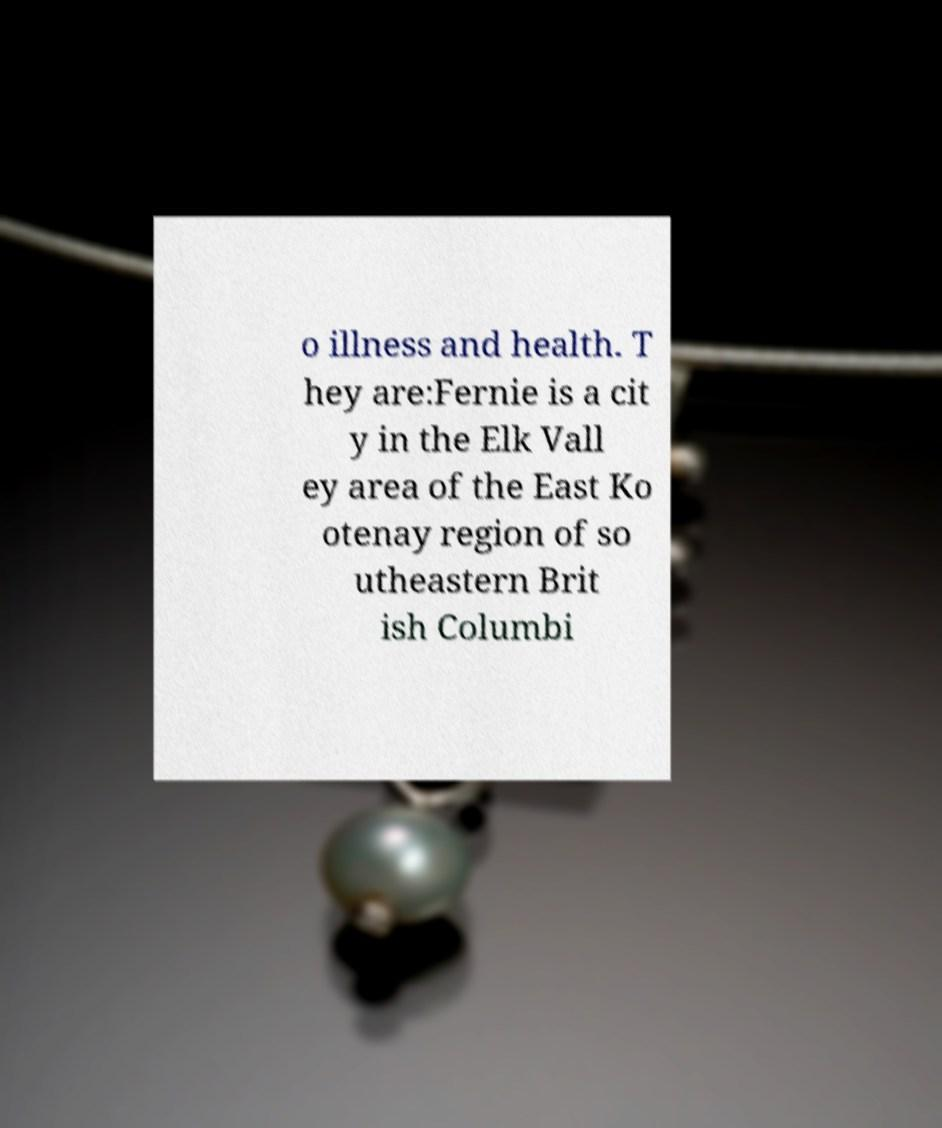For documentation purposes, I need the text within this image transcribed. Could you provide that? o illness and health. T hey are:Fernie is a cit y in the Elk Vall ey area of the East Ko otenay region of so utheastern Brit ish Columbi 